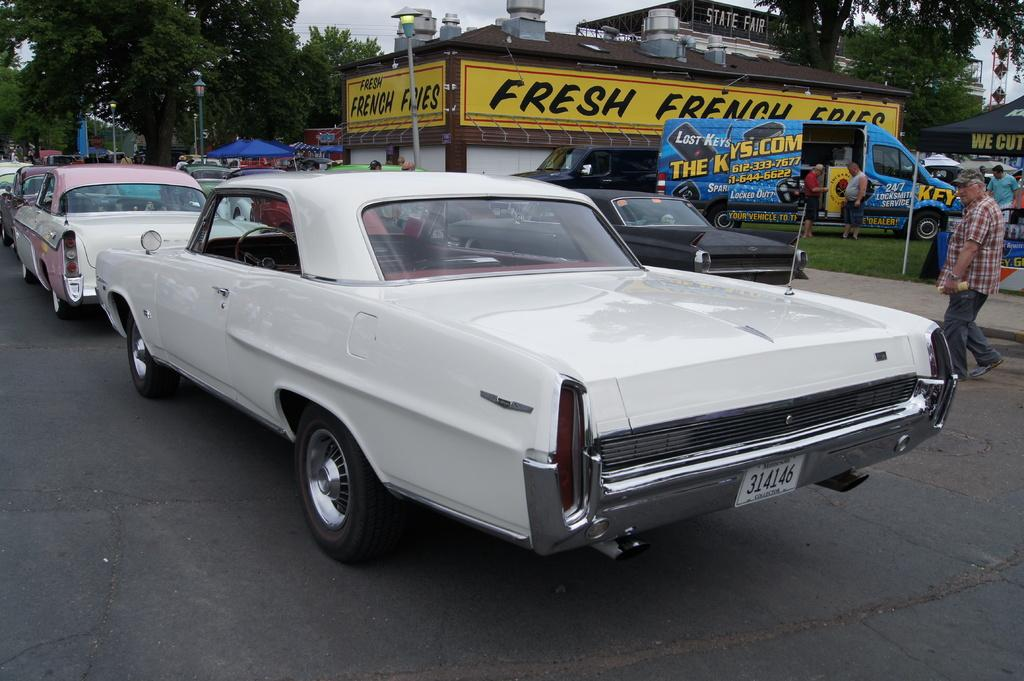What can be seen on the road in the image? There are vehicles on the road in the image. What is visible in the background of the image? There are trees, tents, light poles, a hoarding, the sky, and people in the background. What type of establishment is depicted in the image? The image depicts a mobile canteen. Can you see a carpenter working on a hand in the image? There is no carpenter or hand present in the image. How do the people in the background join the mobile canteen? The image does not show people joining the mobile canteen; it only depicts the canteen and its surroundings. 